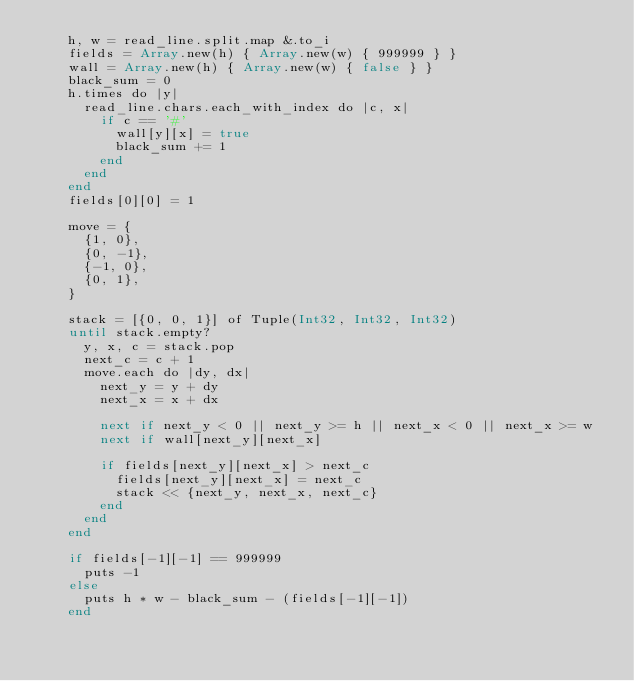<code> <loc_0><loc_0><loc_500><loc_500><_Crystal_>    h, w = read_line.split.map &.to_i
    fields = Array.new(h) { Array.new(w) { 999999 } }
    wall = Array.new(h) { Array.new(w) { false } }
    black_sum = 0
    h.times do |y|
      read_line.chars.each_with_index do |c, x|
        if c == '#'
          wall[y][x] = true
          black_sum += 1
        end
      end
    end
    fields[0][0] = 1

    move = {
      {1, 0},
      {0, -1},
      {-1, 0},
      {0, 1},
    }

    stack = [{0, 0, 1}] of Tuple(Int32, Int32, Int32)
    until stack.empty?
      y, x, c = stack.pop
      next_c = c + 1
      move.each do |dy, dx|
        next_y = y + dy
        next_x = x + dx

        next if next_y < 0 || next_y >= h || next_x < 0 || next_x >= w
        next if wall[next_y][next_x]

        if fields[next_y][next_x] > next_c
          fields[next_y][next_x] = next_c
          stack << {next_y, next_x, next_c}
        end
      end
    end

    if fields[-1][-1] == 999999
      puts -1
    else
      puts h * w - black_sum - (fields[-1][-1])
    end</code> 